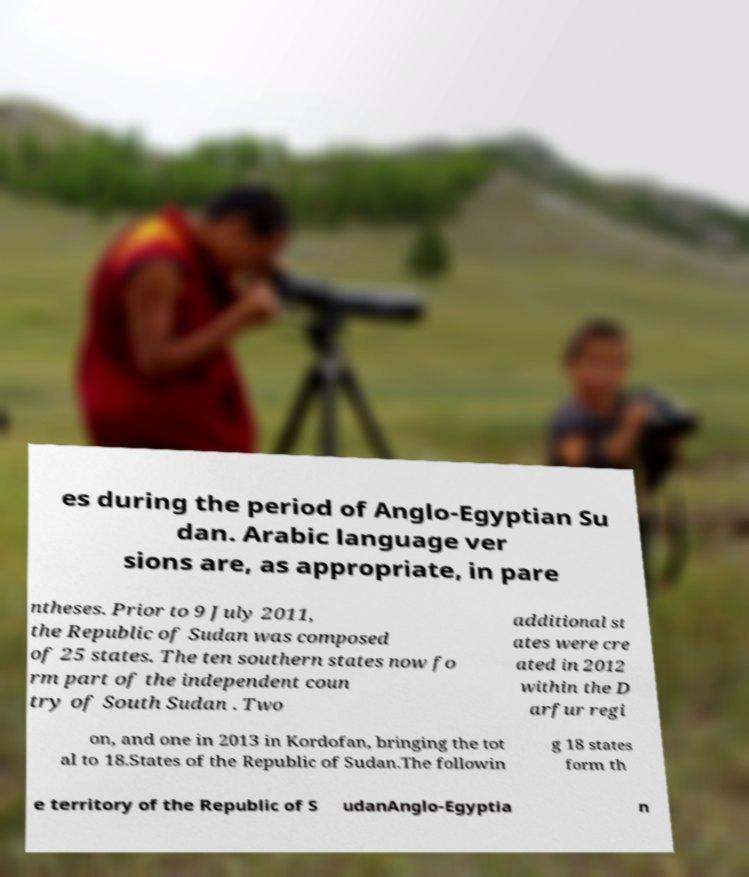I need the written content from this picture converted into text. Can you do that? es during the period of Anglo-Egyptian Su dan. Arabic language ver sions are, as appropriate, in pare ntheses. Prior to 9 July 2011, the Republic of Sudan was composed of 25 states. The ten southern states now fo rm part of the independent coun try of South Sudan . Two additional st ates were cre ated in 2012 within the D arfur regi on, and one in 2013 in Kordofan, bringing the tot al to 18.States of the Republic of Sudan.The followin g 18 states form th e territory of the Republic of S udanAnglo-Egyptia n 